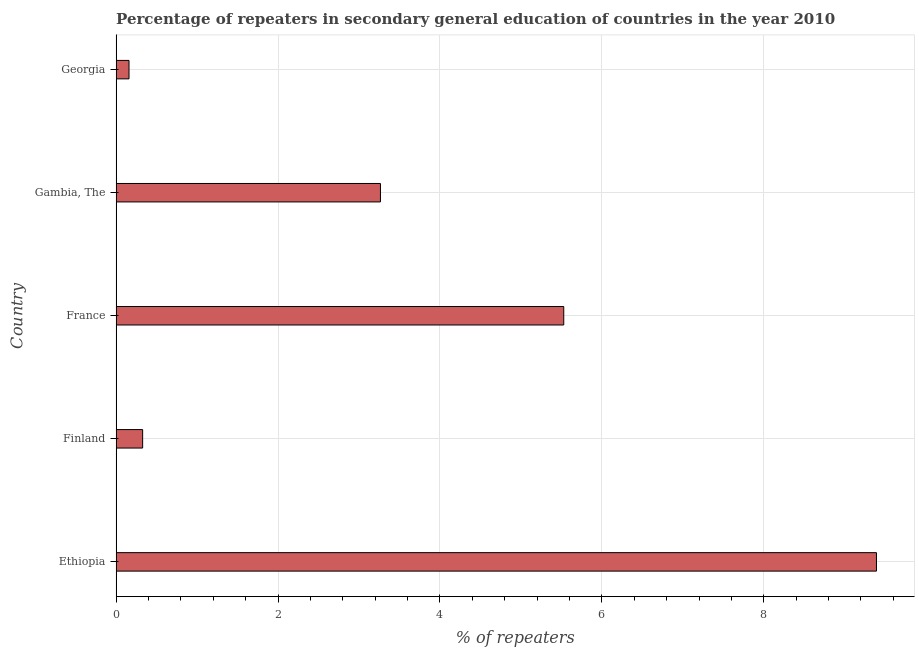Does the graph contain grids?
Your answer should be very brief. Yes. What is the title of the graph?
Your answer should be compact. Percentage of repeaters in secondary general education of countries in the year 2010. What is the label or title of the X-axis?
Ensure brevity in your answer.  % of repeaters. What is the percentage of repeaters in France?
Provide a short and direct response. 5.53. Across all countries, what is the maximum percentage of repeaters?
Ensure brevity in your answer.  9.39. Across all countries, what is the minimum percentage of repeaters?
Give a very brief answer. 0.16. In which country was the percentage of repeaters maximum?
Ensure brevity in your answer.  Ethiopia. In which country was the percentage of repeaters minimum?
Your answer should be compact. Georgia. What is the sum of the percentage of repeaters?
Keep it short and to the point. 18.67. What is the difference between the percentage of repeaters in Finland and Georgia?
Offer a terse response. 0.17. What is the average percentage of repeaters per country?
Make the answer very short. 3.73. What is the median percentage of repeaters?
Offer a terse response. 3.27. What is the ratio of the percentage of repeaters in Ethiopia to that in France?
Offer a very short reply. 1.7. What is the difference between the highest and the second highest percentage of repeaters?
Your response must be concise. 3.86. What is the difference between the highest and the lowest percentage of repeaters?
Make the answer very short. 9.23. How many bars are there?
Ensure brevity in your answer.  5. Are all the bars in the graph horizontal?
Offer a terse response. Yes. How many countries are there in the graph?
Give a very brief answer. 5. What is the % of repeaters of Ethiopia?
Provide a short and direct response. 9.39. What is the % of repeaters of Finland?
Keep it short and to the point. 0.33. What is the % of repeaters in France?
Keep it short and to the point. 5.53. What is the % of repeaters of Gambia, The?
Offer a terse response. 3.27. What is the % of repeaters of Georgia?
Offer a very short reply. 0.16. What is the difference between the % of repeaters in Ethiopia and Finland?
Provide a succinct answer. 9.06. What is the difference between the % of repeaters in Ethiopia and France?
Your response must be concise. 3.86. What is the difference between the % of repeaters in Ethiopia and Gambia, The?
Your answer should be very brief. 6.13. What is the difference between the % of repeaters in Ethiopia and Georgia?
Your answer should be very brief. 9.23. What is the difference between the % of repeaters in Finland and France?
Provide a short and direct response. -5.2. What is the difference between the % of repeaters in Finland and Gambia, The?
Ensure brevity in your answer.  -2.94. What is the difference between the % of repeaters in Finland and Georgia?
Give a very brief answer. 0.17. What is the difference between the % of repeaters in France and Gambia, The?
Provide a succinct answer. 2.26. What is the difference between the % of repeaters in France and Georgia?
Provide a succinct answer. 5.37. What is the difference between the % of repeaters in Gambia, The and Georgia?
Provide a succinct answer. 3.11. What is the ratio of the % of repeaters in Ethiopia to that in Finland?
Ensure brevity in your answer.  28.68. What is the ratio of the % of repeaters in Ethiopia to that in France?
Offer a very short reply. 1.7. What is the ratio of the % of repeaters in Ethiopia to that in Gambia, The?
Your answer should be very brief. 2.88. What is the ratio of the % of repeaters in Ethiopia to that in Georgia?
Your answer should be very brief. 58.99. What is the ratio of the % of repeaters in Finland to that in France?
Give a very brief answer. 0.06. What is the ratio of the % of repeaters in Finland to that in Gambia, The?
Keep it short and to the point. 0.1. What is the ratio of the % of repeaters in Finland to that in Georgia?
Give a very brief answer. 2.06. What is the ratio of the % of repeaters in France to that in Gambia, The?
Provide a succinct answer. 1.69. What is the ratio of the % of repeaters in France to that in Georgia?
Provide a short and direct response. 34.73. What is the ratio of the % of repeaters in Gambia, The to that in Georgia?
Provide a succinct answer. 20.51. 